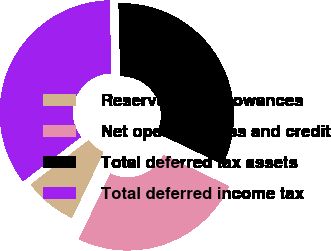Convert chart. <chart><loc_0><loc_0><loc_500><loc_500><pie_chart><fcel>Reserves and allowances<fcel>Net operating loss and credit<fcel>Total deferred tax assets<fcel>Total deferred income tax<nl><fcel>7.48%<fcel>25.02%<fcel>32.5%<fcel>35.0%<nl></chart> 